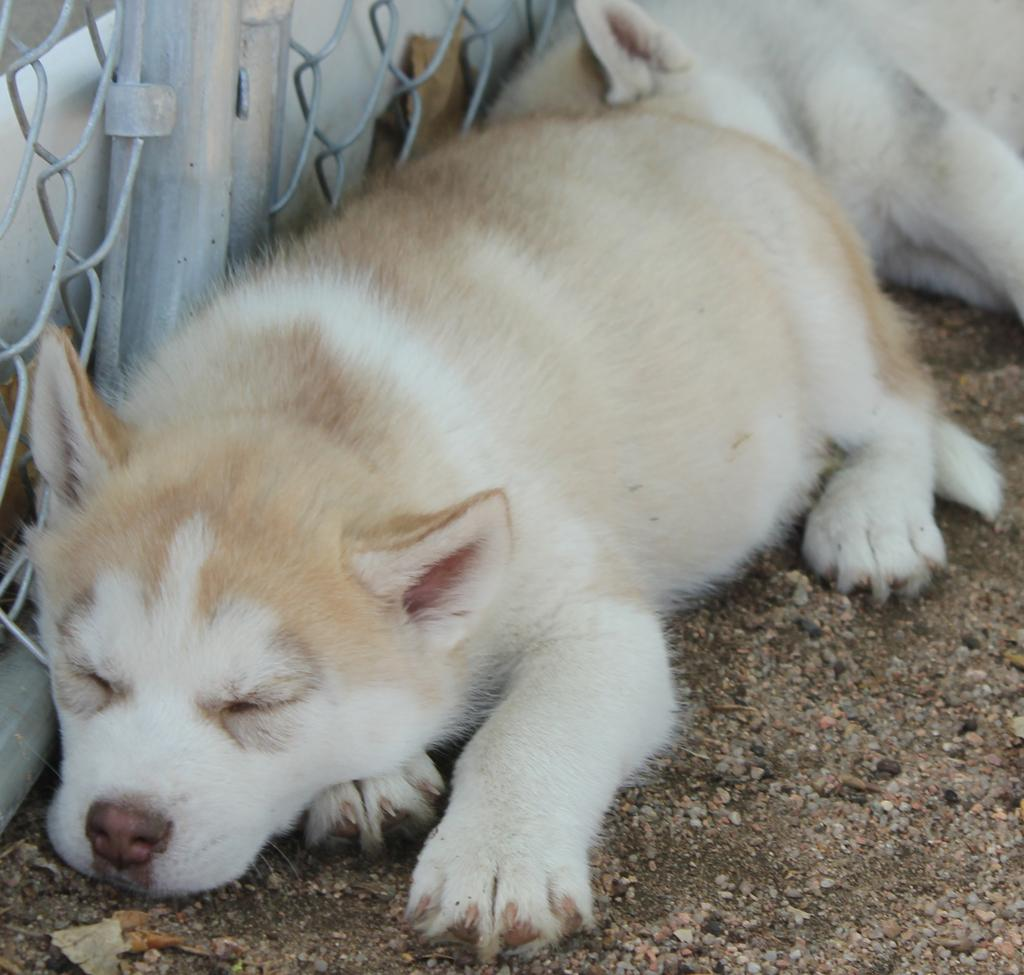What type of animals are present in the image? There are dogs in the image. What surface are the dogs lying on? The dogs are lying on the sand. What is the purpose of the fencing visible in the image? The purpose of the fencing is not explicitly mentioned, but it could be for enclosing an area or providing a boundary. What type of destruction can be seen caused by the icicles in the image? There is no mention of icicles or any destruction in the image; it features dogs lying on the sand with fencing visible. What news event is being reported by the dogs in the image? There is no indication in the image that the dogs are reporting any news event. 